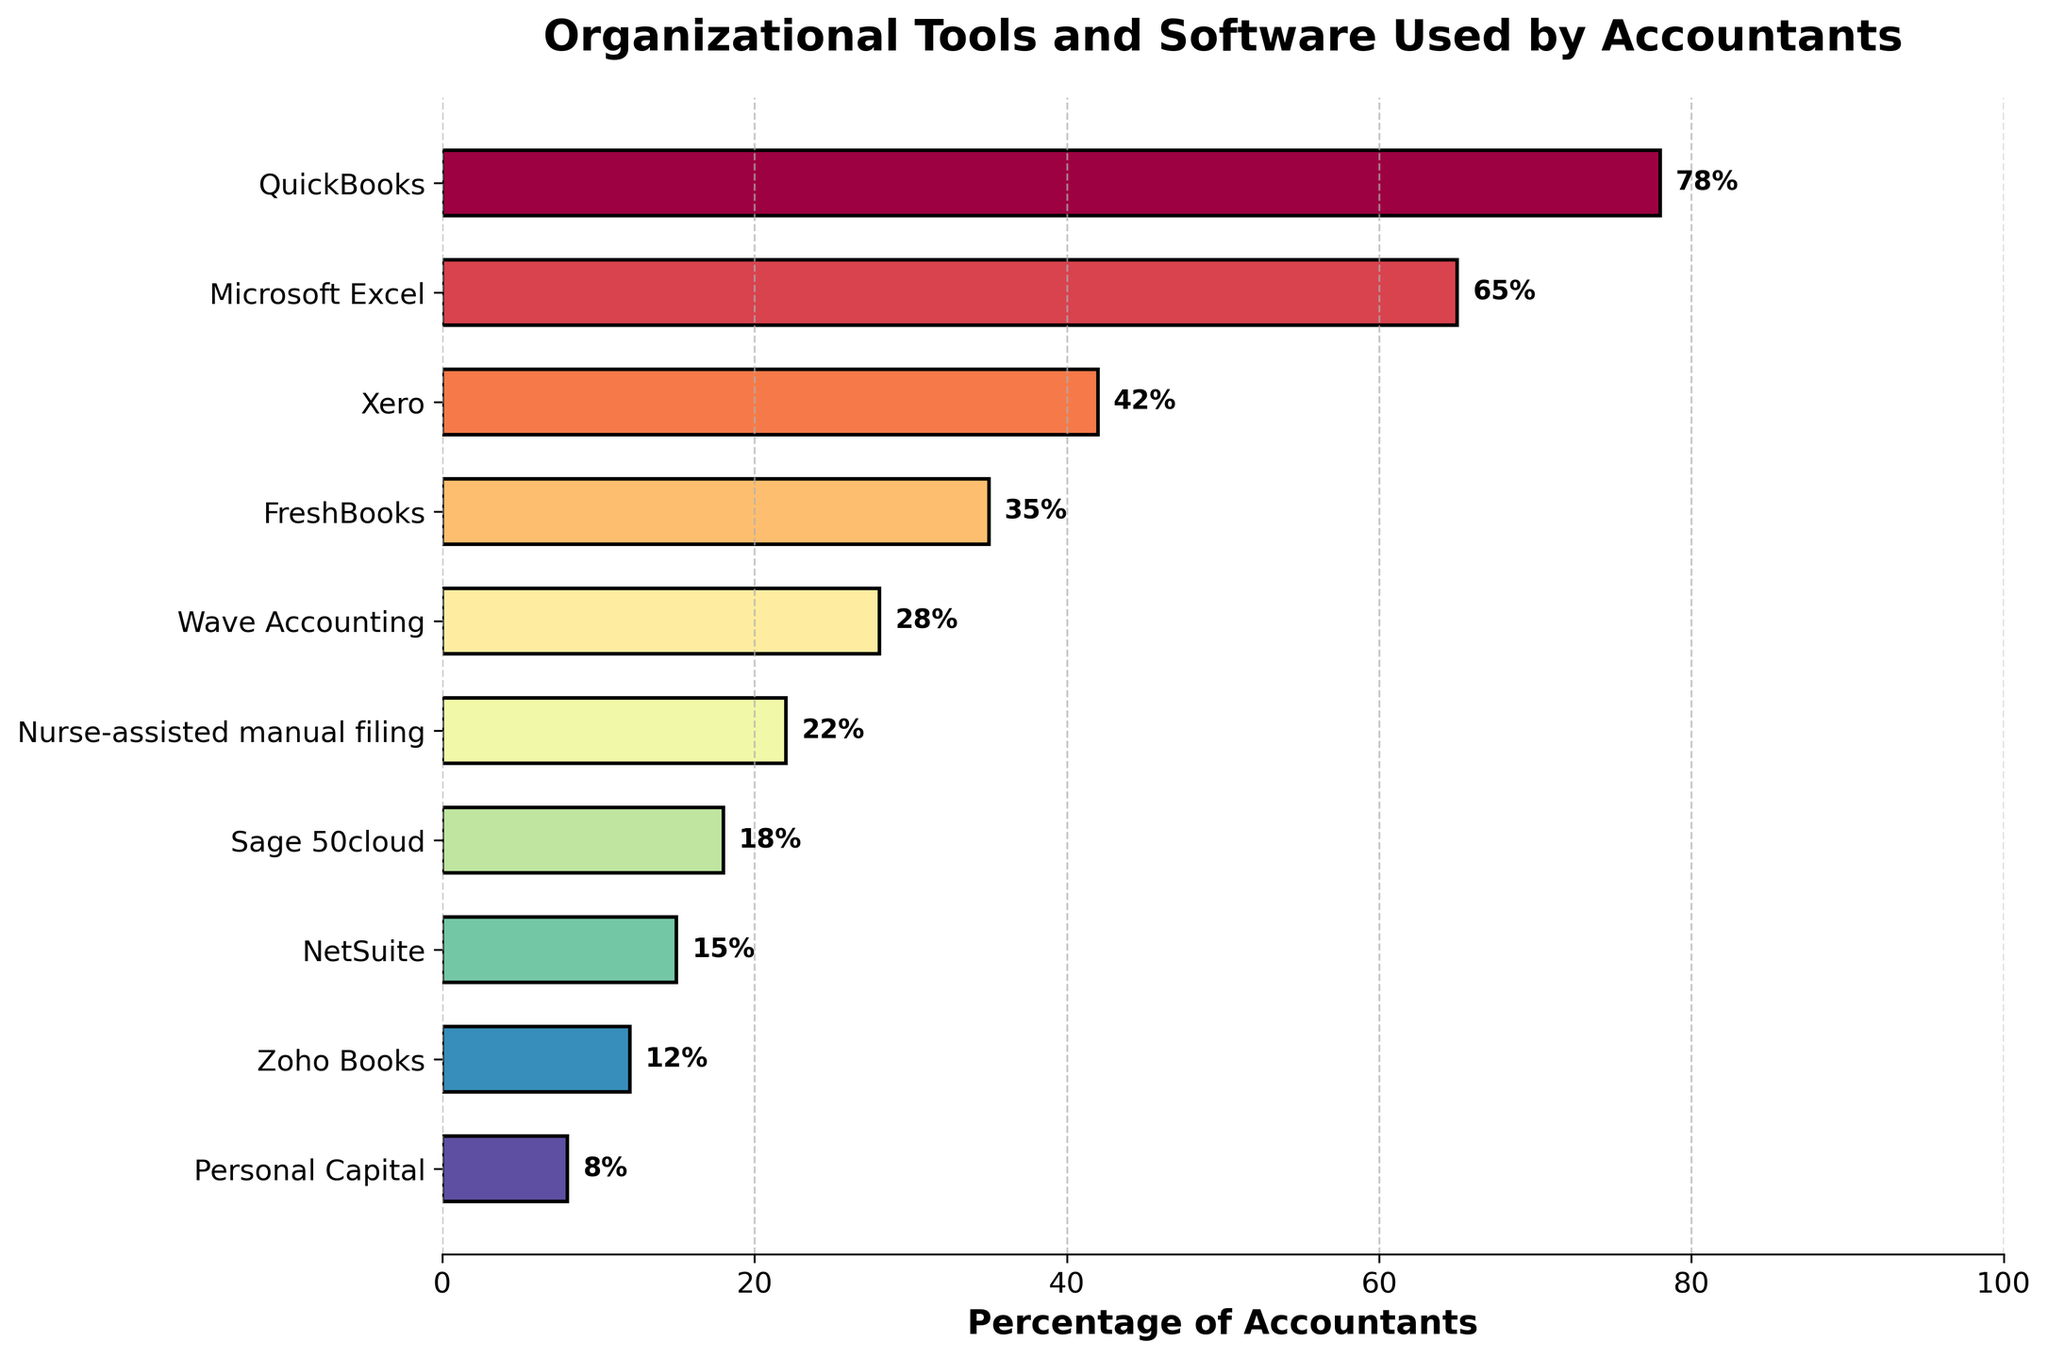Which tool is used by the highest percentage of accountants? The figure shows various organizational tools and their percentages. The bar with the highest percentage represents the most used tool. QuickBooks has the highest percentage, 78%.
Answer: QuickBooks Which tool is used by the lowest percentage of accountants? To find the least used tool, look for the bar with the lowest percentage in the figure. Personal Capital has the lowest percentage, 8%.
Answer: Personal Capital What's the difference in usage percentage between QuickBooks and Microsoft Excel? Subtract the percentage of Microsoft Excel from the percentage of QuickBooks: 78% - 65% = 13%.
Answer: 13% How many tools are used by more than 30% of accountants? Count the bars with percentages greater than 30%. QuickBooks (78%), Microsoft Excel (65%), Xero (42%), and FreshBooks (35%) are used by more than 30% of accountants, so there are 4 tools.
Answer: 4 Which tool, among those used by less than 20% of accountants, has the highest usage percentage? Identify the tools with less than 20% usage and determine which has the highest percentage. Among Sage 50cloud (18%), NetSuite (15%), Zoho Books (12%), and Personal Capital (8%), Sage 50cloud has the highest percentage, 18%.
Answer: Sage 50cloud What is the average percentage usage of the top 3 most used tools? Add the percentages of the top 3 tools and divide by 3: (78% + 65% + 42%) / 3 = 185% / 3 ≈ 61.67%.
Answer: 61.67% What’s the combined percentage usage of Wave Accounting and nurse-assisted manual filing? Add the percentages of Wave Accounting and nurse-assisted manual filing: 28% + 22% = 50%.
Answer: 50% Is Xero used more than twice as much as NetSuite? Compare twice the percentage of NetSuite to Xero: 2 * 15% = 30%. Xero's usage is 42%, which is more than 30%.
Answer: Yes By how much does the usage of FreshBooks exceed that of Zoho Books? Subtract the percentage of Zoho Books from the percentage of FreshBooks: 35% - 12% = 23%.
Answer: 23% Which three tools are the least used by accountants? Identify the tools with the lowest percentages: Sage 50cloud (18%), NetSuite (15%), and Zoho Books (12%) have the lowest usage.
Answer: Sage 50cloud, NetSuite, Zoho Books 